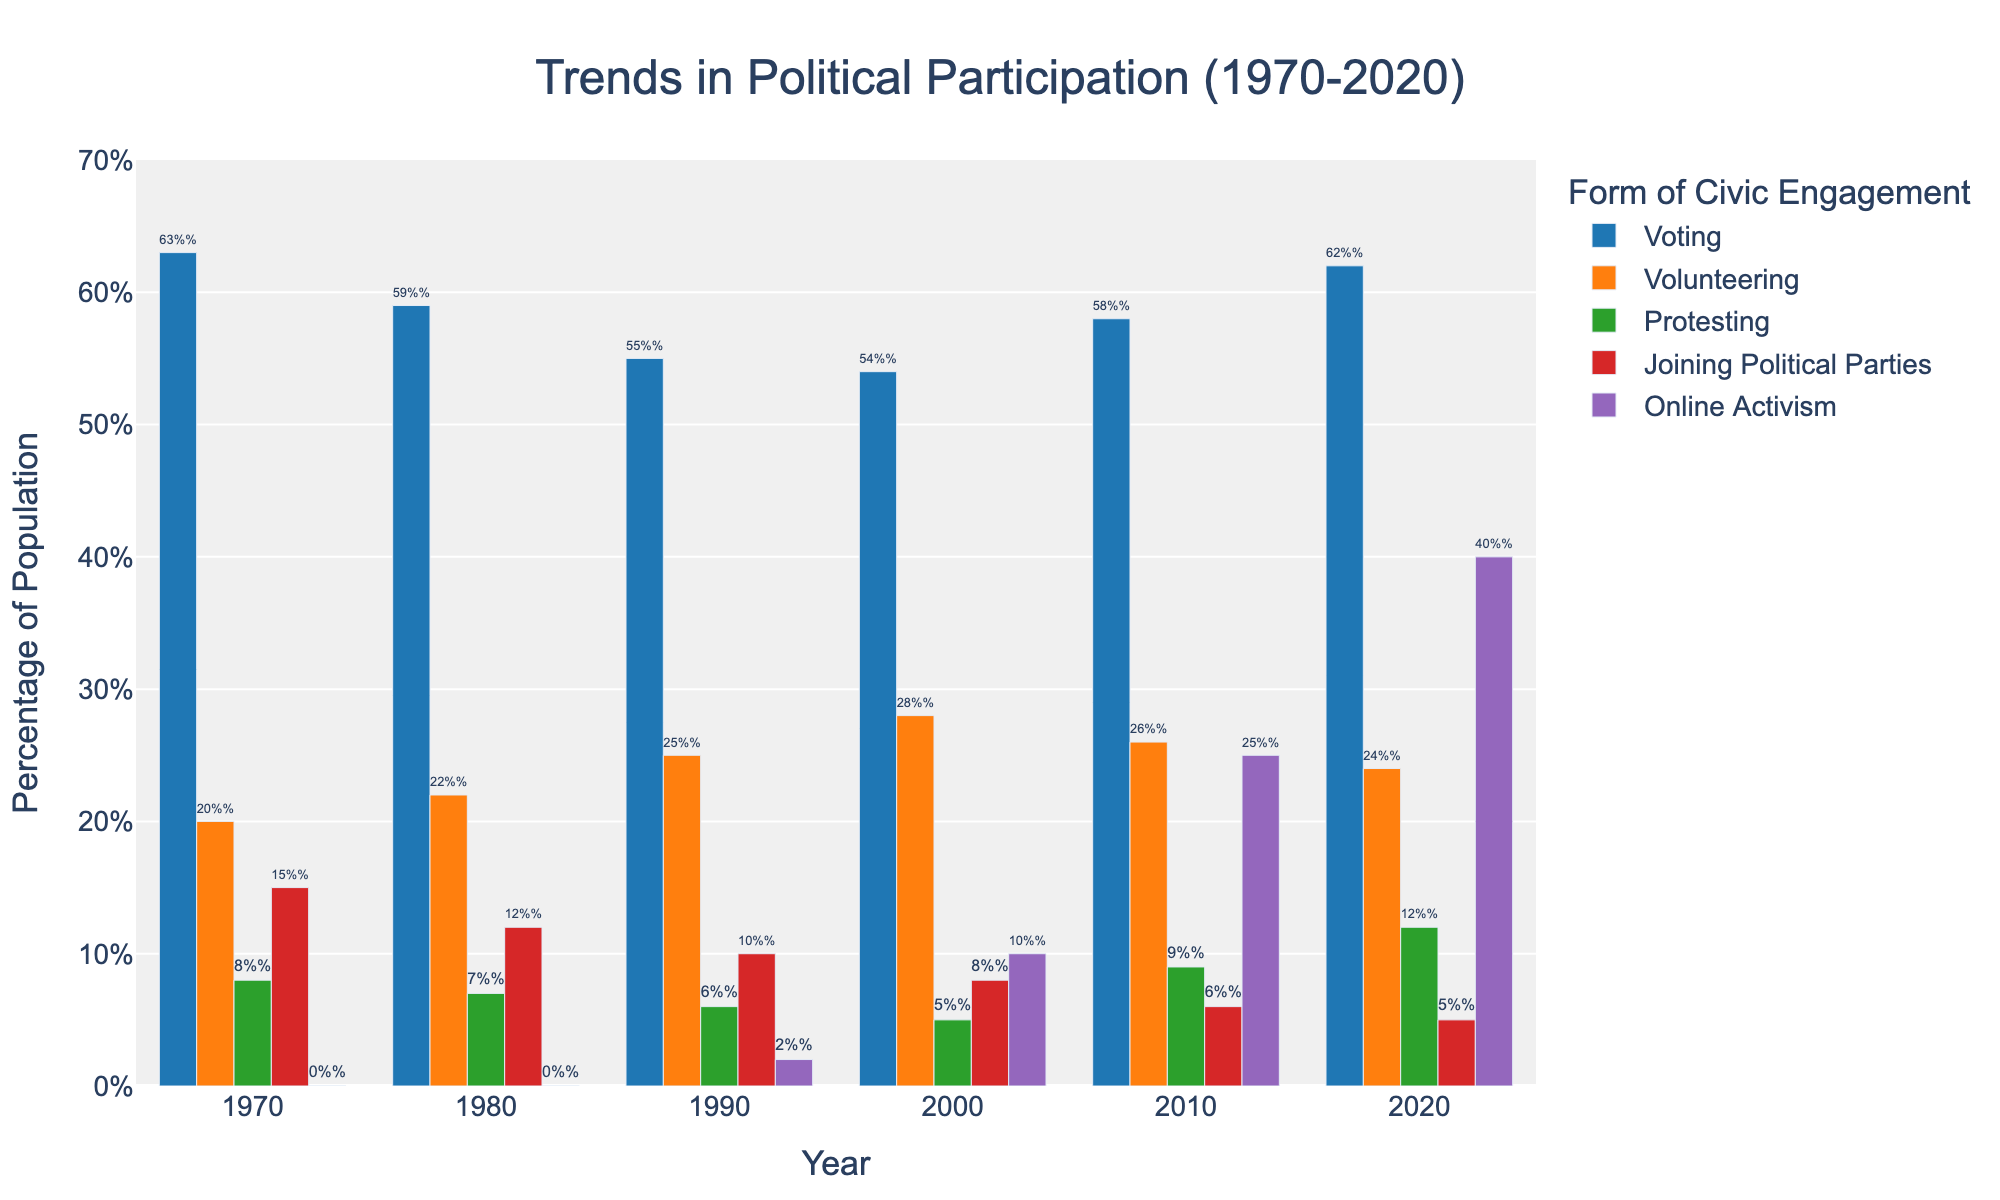What year had the highest percentage of people participating in online activism? To find the answer, examine the bars representing online activism for each year. The tallest bar will indicate the year with the highest percentage. The year 2020 has the tallest bar for online activism at 40%.
Answer: 2020 Which form of civic engagement had the most significant increase over the 50-year span? Compare the starting and ending percentages for each civic engagement category from 1970 to 2020. Online Activism starts at 0% in 1970 and rises to 40% in 2020, signifying the most substantial change.
Answer: Online Activism What is the average percentage of voting over the 50 years? Add the percentages of voting for all the years and divide by the number of years. (63 + 59 + 55 + 54 + 58 + 62)/6 = 351/6 = 58.5%
Answer: 58.5% Which year showed the lowest percentage of people joining political parties? Examine the bars representing joining political parties for each year to find the shortest one. The year 2020 has the shortest bar for joining political parties at 5%.
Answer: 2020 How did protesting change from 2000 to 2020? Subtract the percentage in 2000 (5%) from the percentage in 2020 (12%). The increase is 12% - 5% = 7%.
Answer: Increased by 7% Which form of civic engagement had the least fluctuation over the years? Examine the visual height differences in the bars for each form of civic engagement across the years. Joining Political Parties shows little change (from 15% in 1970 to 5% in 2020).
Answer: Joining Political Parties How many more people were voting than volunteering in 2010? Subtract the percentage of volunteering from voting in 2010. Voting: 58%, Volunteering: 26%. 58% - 26% = 32%
Answer: 32% more What was the trend for volunteering from 1970 to 2020? Examine the bars for volunteering over the years. Volunteering increases slightly from 20% in 1970 to 24% in 2020.
Answer: Slight Increase Compare the participation in volunteering and protesting in 1990. Which was more popular and by how much? Look at the bars for volunteering and protesting in 1990. Volunteering is at 25%, and protesting is at 6%. 25% - 6% = 19%.
Answer: Volunteering by 19% Which form of civic engagement had a higher percentage in 1980, voting or joining political parties? Compare the bars for voting (59%) and joining political parties (12%) in 1980. Voting is higher at 59%.
Answer: Voting 